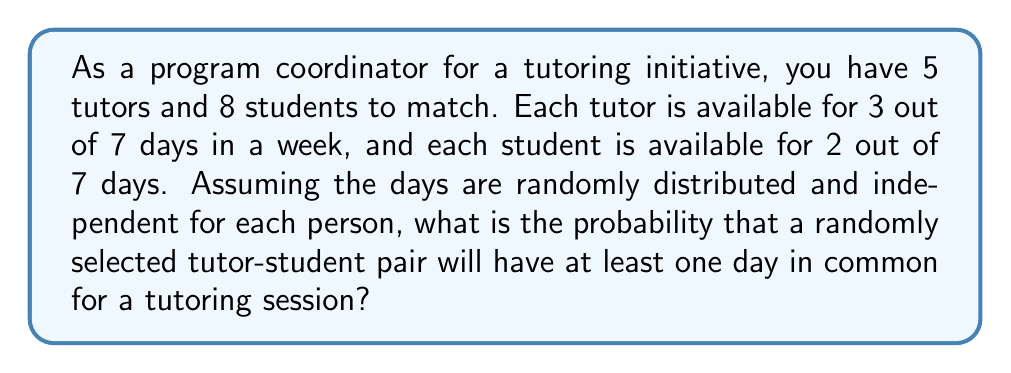Show me your answer to this math problem. Let's approach this step-by-step:

1) First, we need to calculate the probability that a tutor and a student have no days in common. This is easier than calculating the probability of having at least one day in common.

2) For a tutor and student to have no days in common:
   - The tutor is available for 3 days out of 7
   - The student must be available on 2 of the 4 remaining days

3) The probability of the student being available on 2 of the 4 remaining days can be calculated using the combination formula:

   $$P(\text{no common days}) = \frac{\binom{4}{2}}{\binom{7}{2}}$$

4) Let's calculate this:
   $$\binom{4}{2} = \frac{4!}{2!(4-2)!} = \frac{4 \cdot 3}{2 \cdot 1} = 6$$
   $$\binom{7}{2} = \frac{7!}{2!(7-2)!} = \frac{7 \cdot 6}{2 \cdot 1} = 21$$

   $$P(\text{no common days}) = \frac{6}{21} = \frac{2}{7}$$

5) Therefore, the probability of having at least one day in common is the complement of this probability:

   $$P(\text{at least one common day}) = 1 - P(\text{no common days}) = 1 - \frac{2}{7} = \frac{5}{7}$$

6) We can express this as a decimal or percentage:
   $$\frac{5}{7} \approx 0.7143 \text{ or } 71.43\%$$
Answer: The probability that a randomly selected tutor-student pair will have at least one day in common for a tutoring session is $\frac{5}{7}$ or approximately 71.43%. 